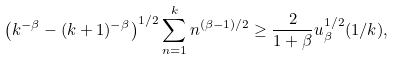Convert formula to latex. <formula><loc_0><loc_0><loc_500><loc_500>\left ( k ^ { - \beta } - ( k + 1 ) ^ { - \beta } \right ) ^ { 1 / 2 } \sum ^ { k } _ { n = 1 } n ^ { ( \beta - 1 ) / 2 } \geq \frac { 2 } { 1 + \beta } u ^ { 1 / 2 } _ { \beta } ( 1 / k ) ,</formula> 